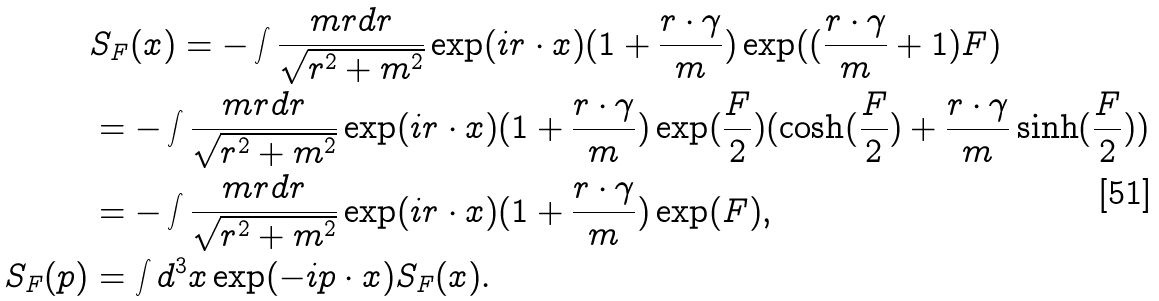Convert formula to latex. <formula><loc_0><loc_0><loc_500><loc_500>& S _ { F } ( x ) = - \int \frac { m r d r } { \sqrt { r ^ { 2 } + m ^ { 2 } } } \exp ( i r \cdot x ) ( 1 + \frac { r \cdot \gamma } { m } ) \exp ( ( \frac { r \cdot \gamma } { m } + 1 ) F ) \\ & = - \int \frac { m r d r } { \sqrt { r ^ { 2 } + m ^ { 2 } } } \exp ( i r \cdot x ) ( 1 + \frac { r \cdot \gamma } { m } ) \exp ( \frac { F } { 2 } ) ( \cosh ( \frac { F } { 2 } ) + \frac { r \cdot \gamma } { m } \sinh ( \frac { F } { 2 } ) ) \\ & = - \int \frac { m r d r } { \sqrt { r ^ { 2 } + m ^ { 2 } } } \exp ( i r \cdot x ) ( 1 + \frac { r \cdot \gamma } { m } ) \exp ( F ) , \\ S _ { F } ( p ) & = \int d ^ { 3 } x \exp ( - i p \cdot x ) S _ { F } ( x ) .</formula> 